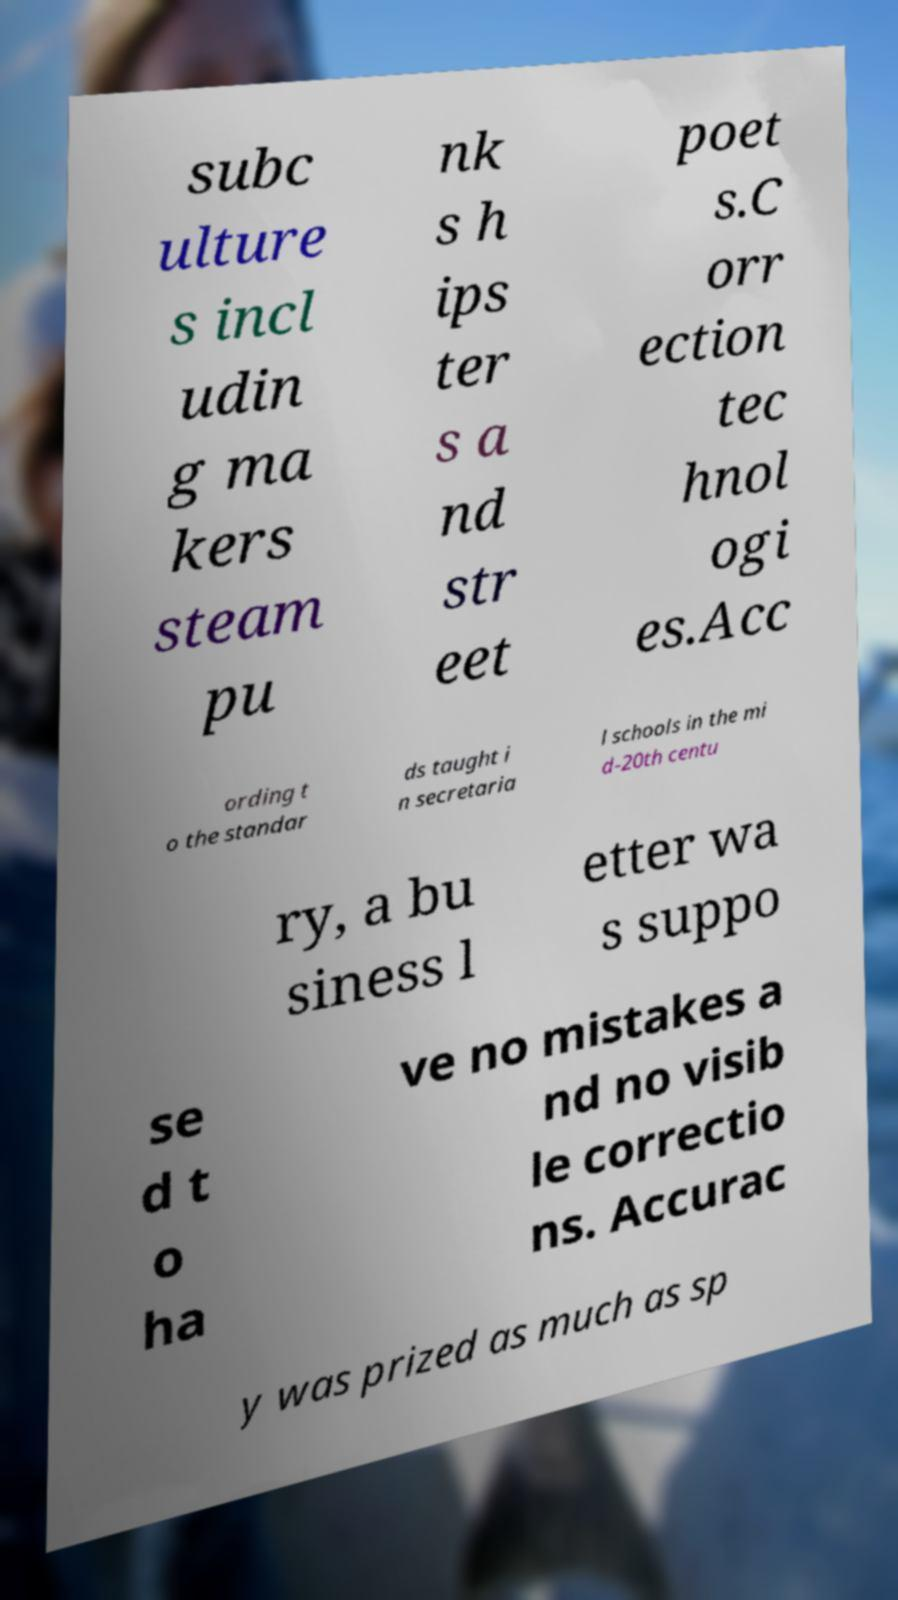Please read and relay the text visible in this image. What does it say? subc ulture s incl udin g ma kers steam pu nk s h ips ter s a nd str eet poet s.C orr ection tec hnol ogi es.Acc ording t o the standar ds taught i n secretaria l schools in the mi d-20th centu ry, a bu siness l etter wa s suppo se d t o ha ve no mistakes a nd no visib le correctio ns. Accurac y was prized as much as sp 